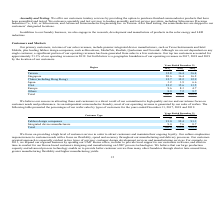According to United Micro Electronics's financial document, What does the company culture emphasize on? Our culture emphasizes responsiveness to customer needs with a focus on flexibility, speed and accuracy throughout our manufacturing and delivery processes. The document states: "act customers and maintain their ongoing loyalty. Our culture emphasizes responsiveness to customer needs with a focus on flexibility, speed and accur..." Also, What is the major portion of the operating revenue? According to the financial document, wafers. The relevant text states: "ur operating revenue is generated by our sales of wafers. The following table presented the percentages of our wafer sales by types of customers for the yea..." Also, What is the approach taken by the company to grow its business? Based on the financial document, the answer is Our customer oriented approach is especially evident in two types of services: customer design development services and manufacturing services.. Also, can you calculate: What is the increase / (decrease) in the Fabless design companies from 2018 to 2019? Based on the calculation: 91.3% - 92.4%, the result is -1.1 (percentage). This is based on the information: "018 2019 % % % Fabless design companies 91.0 92.4 91.3 Integrated device manufacturers 9.0 7.6 8.7 Total 100.0 100.0 100.0 017 2018 2019 % % % Fabless design companies 91.0 92.4 91.3 Integrated device..." The key data points involved are: 91.3, 92.4. Also, can you calculate: What is the average of Integrated device manufacturers? To answer this question, I need to perform calculations using the financial data. The calculation is: (9.0% + 7.6% + 8.7%) / 3, which equals 8.43 (percentage). This is based on the information: "es 91.0 92.4 91.3 Integrated device manufacturers 9.0 7.6 8.7 Total 100.0 100.0 100.0 1.0 92.4 91.3 Integrated device manufacturers 9.0 7.6 8.7 Total 100.0 100.0 100.0 China (including Hong Kong) 12.7..." The key data points involved are: 7.6, 8.7, 9.0. Also, can you calculate: What is the increase / (decrease) in the Integrated device manufacturers from 2017 to 2018? Based on the calculation: 7.6% - 9.0%, the result is -1.4 (percentage). This is based on the information: "es 91.0 92.4 91.3 Integrated device manufacturers 9.0 7.6 8.7 Total 100.0 100.0 100.0 1.0 92.4 91.3 Integrated device manufacturers 9.0 7.6 8.7 Total 100.0 100.0 100.0..." The key data points involved are: 7.6, 9.0. 